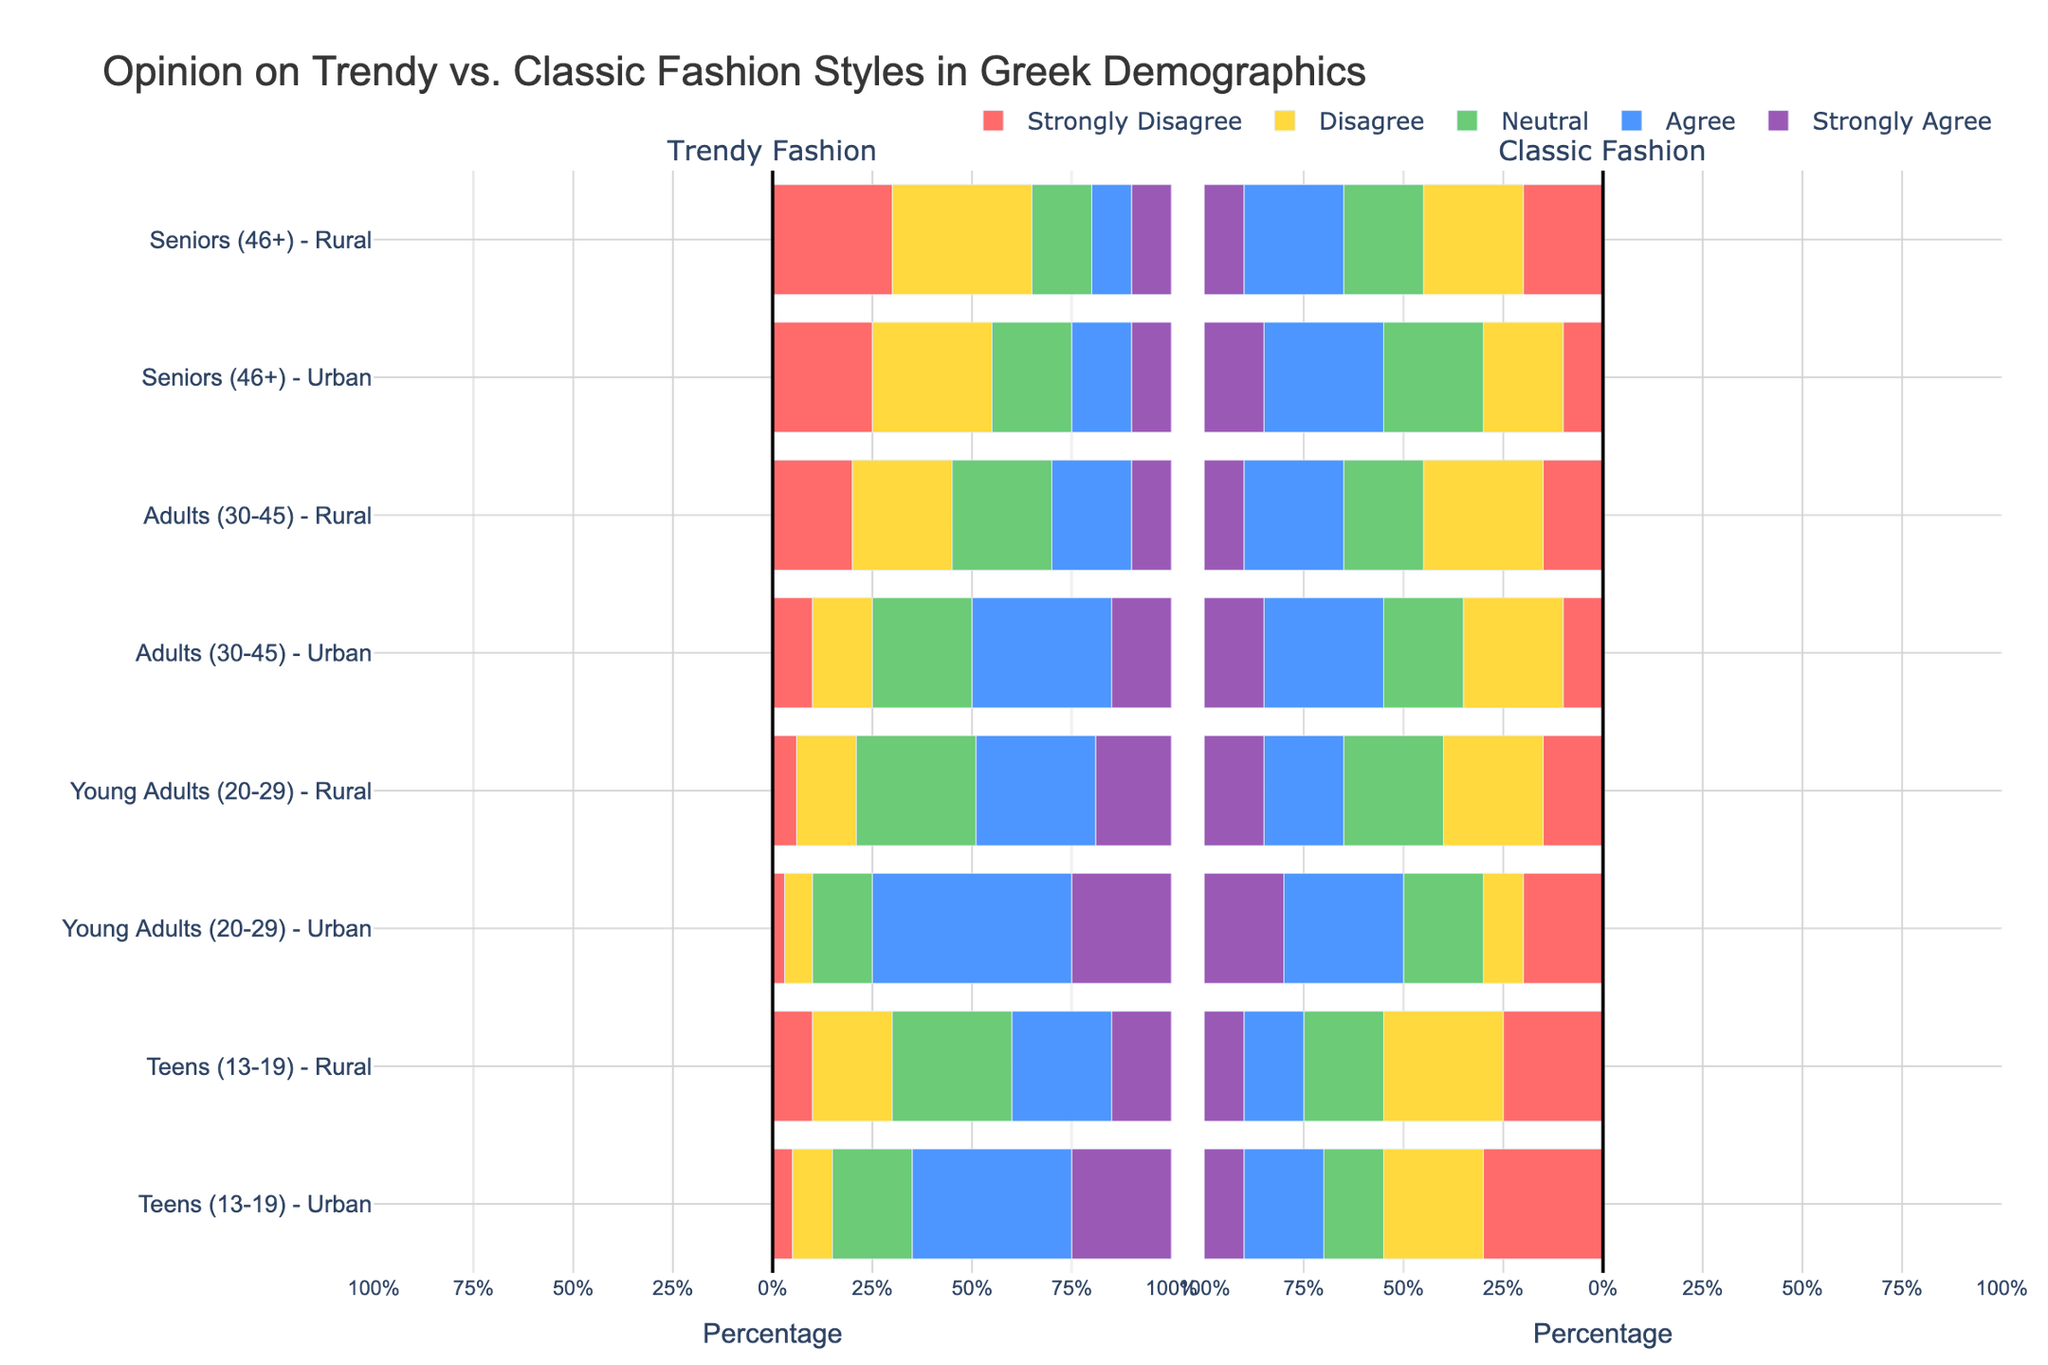Which demographic group has the highest rate of support for trendy fashion styles? Look at the stacked bars for trendy fashion in the figure. The group with the longest combined bars leaning towards the right side for 'Agree' and 'Strongly Agree' represents the highest support.
Answer: Young Adults (20-29) - Urban Which group has the lowest rate of support for classic fashion styles? Check the stacked bars for classic fashion styles. The group with the shortest combined bars leaning towards the left side for 'Agree' and 'Strongly Agree' has the lowest support.
Answer: Teens (13-19) - Urban Between urban and rural seniors, who are more likely to disagree with trendy fashion? Compare the heights of the 'Disagree' and 'Strongly Disagree' sections of the urban and rural seniors for trendy fashion.
Answer: Rural seniors How does the preference for neutral opinions on classic fashion compare between urban teens and rural teens? Look at the 'Neutral' section of classic fashion for both urban teens and rural teens. Compare the lengths of these sections.
Answer: Rural teens have a higher neutral opinion What is the combined percentage of young adults (urban) who agree or strongly agree with trendy fashion styles? Summing up the 'Agree' and 'Strongly Agree' percentages for young adults (urban) in trendy fashion. 50% + 25% = 75%.
Answer: 75% Among adults (30-45) - urban, which type of fashion has more neutral opinions? Compare the 'Neutral' section lengths for trendy and classic fashion among adults (30-45) - urban.
Answer: Trendy fashion Which demographic shows the highest percentage of strong agreement for classic fashion styles? Look at the 'Strongly Agree' section for classic fashion across all demographics. The demographic with the longest section has the highest percentage of strong agreement.
Answer: Young Adults (20-29) - Urban How do the support levels for trendy fashion styles in urban teens compare to rural teens? Compare each section ('Strongly Disagree', 'Disagree', 'Neutral', 'Agree', 'Strongly Agree') between urban and rural teens for trendy fashion.
Answer: Urban teens have higher support What is the difference in the overall positive support (Agree + Strongly Agree) for trendy fashion between urban and rural young adults? Calculate the positive support percentages for trendy fashion in both demographics and find the difference: (50% + 25%) - (30% + 19%).
Answer: 26% Which group has a higher disagree rate with classic fashion: urban adults (30-45) or rural adults (30-45)? Compare the 'Disagree' sections for classic fashion of the two groups.
Answer: Rural adults (30-45) 